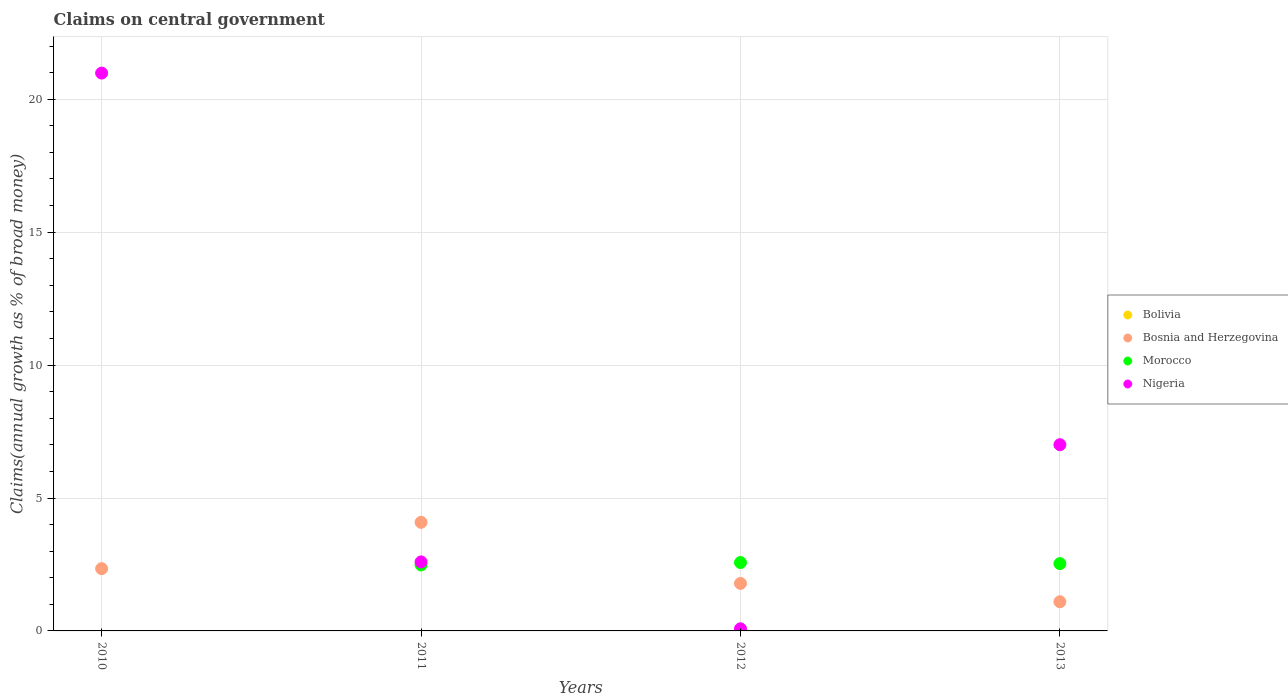How many different coloured dotlines are there?
Your answer should be very brief. 3. What is the percentage of broad money claimed on centeral government in Bosnia and Herzegovina in 2013?
Your answer should be compact. 1.1. Across all years, what is the maximum percentage of broad money claimed on centeral government in Morocco?
Ensure brevity in your answer.  2.57. Across all years, what is the minimum percentage of broad money claimed on centeral government in Nigeria?
Offer a terse response. 0.08. In which year was the percentage of broad money claimed on centeral government in Nigeria maximum?
Your answer should be compact. 2010. What is the total percentage of broad money claimed on centeral government in Nigeria in the graph?
Make the answer very short. 30.66. What is the difference between the percentage of broad money claimed on centeral government in Morocco in 2012 and that in 2013?
Make the answer very short. 0.04. What is the difference between the percentage of broad money claimed on centeral government in Bosnia and Herzegovina in 2011 and the percentage of broad money claimed on centeral government in Morocco in 2013?
Your answer should be compact. 1.55. What is the average percentage of broad money claimed on centeral government in Bosnia and Herzegovina per year?
Your answer should be very brief. 2.33. In the year 2010, what is the difference between the percentage of broad money claimed on centeral government in Bosnia and Herzegovina and percentage of broad money claimed on centeral government in Nigeria?
Provide a succinct answer. -18.64. In how many years, is the percentage of broad money claimed on centeral government in Morocco greater than 16 %?
Offer a very short reply. 0. What is the ratio of the percentage of broad money claimed on centeral government in Morocco in 2012 to that in 2013?
Your answer should be very brief. 1.02. Is the difference between the percentage of broad money claimed on centeral government in Bosnia and Herzegovina in 2011 and 2012 greater than the difference between the percentage of broad money claimed on centeral government in Nigeria in 2011 and 2012?
Keep it short and to the point. No. What is the difference between the highest and the second highest percentage of broad money claimed on centeral government in Nigeria?
Give a very brief answer. 13.98. What is the difference between the highest and the lowest percentage of broad money claimed on centeral government in Nigeria?
Make the answer very short. 20.9. Is the sum of the percentage of broad money claimed on centeral government in Morocco in 2012 and 2013 greater than the maximum percentage of broad money claimed on centeral government in Bosnia and Herzegovina across all years?
Your response must be concise. Yes. Is it the case that in every year, the sum of the percentage of broad money claimed on centeral government in Bosnia and Herzegovina and percentage of broad money claimed on centeral government in Bolivia  is greater than the sum of percentage of broad money claimed on centeral government in Morocco and percentage of broad money claimed on centeral government in Nigeria?
Ensure brevity in your answer.  No. Does the percentage of broad money claimed on centeral government in Nigeria monotonically increase over the years?
Provide a succinct answer. No. Is the percentage of broad money claimed on centeral government in Bolivia strictly greater than the percentage of broad money claimed on centeral government in Morocco over the years?
Keep it short and to the point. No. Is the percentage of broad money claimed on centeral government in Bolivia strictly less than the percentage of broad money claimed on centeral government in Nigeria over the years?
Ensure brevity in your answer.  Yes. How many dotlines are there?
Provide a short and direct response. 3. How many years are there in the graph?
Your answer should be compact. 4. Are the values on the major ticks of Y-axis written in scientific E-notation?
Keep it short and to the point. No. Does the graph contain any zero values?
Ensure brevity in your answer.  Yes. Does the graph contain grids?
Your response must be concise. Yes. What is the title of the graph?
Your answer should be very brief. Claims on central government. Does "Tanzania" appear as one of the legend labels in the graph?
Make the answer very short. No. What is the label or title of the X-axis?
Your answer should be very brief. Years. What is the label or title of the Y-axis?
Provide a succinct answer. Claims(annual growth as % of broad money). What is the Claims(annual growth as % of broad money) of Bolivia in 2010?
Keep it short and to the point. 0. What is the Claims(annual growth as % of broad money) of Bosnia and Herzegovina in 2010?
Make the answer very short. 2.34. What is the Claims(annual growth as % of broad money) of Morocco in 2010?
Offer a very short reply. 0. What is the Claims(annual growth as % of broad money) of Nigeria in 2010?
Your answer should be very brief. 20.98. What is the Claims(annual growth as % of broad money) in Bolivia in 2011?
Offer a very short reply. 0. What is the Claims(annual growth as % of broad money) in Bosnia and Herzegovina in 2011?
Provide a short and direct response. 4.08. What is the Claims(annual growth as % of broad money) of Morocco in 2011?
Keep it short and to the point. 2.48. What is the Claims(annual growth as % of broad money) in Nigeria in 2011?
Offer a terse response. 2.6. What is the Claims(annual growth as % of broad money) in Bolivia in 2012?
Ensure brevity in your answer.  0. What is the Claims(annual growth as % of broad money) of Bosnia and Herzegovina in 2012?
Give a very brief answer. 1.79. What is the Claims(annual growth as % of broad money) in Morocco in 2012?
Your answer should be very brief. 2.57. What is the Claims(annual growth as % of broad money) in Nigeria in 2012?
Give a very brief answer. 0.08. What is the Claims(annual growth as % of broad money) of Bosnia and Herzegovina in 2013?
Offer a very short reply. 1.1. What is the Claims(annual growth as % of broad money) in Morocco in 2013?
Provide a short and direct response. 2.53. What is the Claims(annual growth as % of broad money) in Nigeria in 2013?
Your answer should be compact. 7.01. Across all years, what is the maximum Claims(annual growth as % of broad money) of Bosnia and Herzegovina?
Ensure brevity in your answer.  4.08. Across all years, what is the maximum Claims(annual growth as % of broad money) in Morocco?
Make the answer very short. 2.57. Across all years, what is the maximum Claims(annual growth as % of broad money) of Nigeria?
Your answer should be very brief. 20.98. Across all years, what is the minimum Claims(annual growth as % of broad money) of Bosnia and Herzegovina?
Your response must be concise. 1.1. Across all years, what is the minimum Claims(annual growth as % of broad money) in Morocco?
Make the answer very short. 0. Across all years, what is the minimum Claims(annual growth as % of broad money) in Nigeria?
Keep it short and to the point. 0.08. What is the total Claims(annual growth as % of broad money) of Bolivia in the graph?
Make the answer very short. 0. What is the total Claims(annual growth as % of broad money) in Bosnia and Herzegovina in the graph?
Your response must be concise. 9.31. What is the total Claims(annual growth as % of broad money) in Morocco in the graph?
Your answer should be compact. 7.59. What is the total Claims(annual growth as % of broad money) in Nigeria in the graph?
Make the answer very short. 30.66. What is the difference between the Claims(annual growth as % of broad money) in Bosnia and Herzegovina in 2010 and that in 2011?
Provide a short and direct response. -1.74. What is the difference between the Claims(annual growth as % of broad money) of Nigeria in 2010 and that in 2011?
Ensure brevity in your answer.  18.39. What is the difference between the Claims(annual growth as % of broad money) in Bosnia and Herzegovina in 2010 and that in 2012?
Keep it short and to the point. 0.56. What is the difference between the Claims(annual growth as % of broad money) of Nigeria in 2010 and that in 2012?
Provide a succinct answer. 20.9. What is the difference between the Claims(annual growth as % of broad money) of Bosnia and Herzegovina in 2010 and that in 2013?
Your answer should be compact. 1.25. What is the difference between the Claims(annual growth as % of broad money) of Nigeria in 2010 and that in 2013?
Your response must be concise. 13.98. What is the difference between the Claims(annual growth as % of broad money) in Bosnia and Herzegovina in 2011 and that in 2012?
Provide a short and direct response. 2.3. What is the difference between the Claims(annual growth as % of broad money) in Morocco in 2011 and that in 2012?
Provide a succinct answer. -0.09. What is the difference between the Claims(annual growth as % of broad money) of Nigeria in 2011 and that in 2012?
Keep it short and to the point. 2.52. What is the difference between the Claims(annual growth as % of broad money) of Bosnia and Herzegovina in 2011 and that in 2013?
Make the answer very short. 2.99. What is the difference between the Claims(annual growth as % of broad money) in Morocco in 2011 and that in 2013?
Your answer should be compact. -0.05. What is the difference between the Claims(annual growth as % of broad money) of Nigeria in 2011 and that in 2013?
Your response must be concise. -4.41. What is the difference between the Claims(annual growth as % of broad money) in Bosnia and Herzegovina in 2012 and that in 2013?
Provide a succinct answer. 0.69. What is the difference between the Claims(annual growth as % of broad money) of Morocco in 2012 and that in 2013?
Offer a terse response. 0.04. What is the difference between the Claims(annual growth as % of broad money) of Nigeria in 2012 and that in 2013?
Make the answer very short. -6.93. What is the difference between the Claims(annual growth as % of broad money) of Bosnia and Herzegovina in 2010 and the Claims(annual growth as % of broad money) of Morocco in 2011?
Your answer should be very brief. -0.14. What is the difference between the Claims(annual growth as % of broad money) of Bosnia and Herzegovina in 2010 and the Claims(annual growth as % of broad money) of Nigeria in 2011?
Keep it short and to the point. -0.25. What is the difference between the Claims(annual growth as % of broad money) in Bosnia and Herzegovina in 2010 and the Claims(annual growth as % of broad money) in Morocco in 2012?
Your answer should be compact. -0.23. What is the difference between the Claims(annual growth as % of broad money) in Bosnia and Herzegovina in 2010 and the Claims(annual growth as % of broad money) in Nigeria in 2012?
Offer a very short reply. 2.26. What is the difference between the Claims(annual growth as % of broad money) of Bosnia and Herzegovina in 2010 and the Claims(annual growth as % of broad money) of Morocco in 2013?
Offer a terse response. -0.19. What is the difference between the Claims(annual growth as % of broad money) of Bosnia and Herzegovina in 2010 and the Claims(annual growth as % of broad money) of Nigeria in 2013?
Your answer should be very brief. -4.66. What is the difference between the Claims(annual growth as % of broad money) in Bosnia and Herzegovina in 2011 and the Claims(annual growth as % of broad money) in Morocco in 2012?
Keep it short and to the point. 1.51. What is the difference between the Claims(annual growth as % of broad money) in Bosnia and Herzegovina in 2011 and the Claims(annual growth as % of broad money) in Nigeria in 2012?
Your response must be concise. 4. What is the difference between the Claims(annual growth as % of broad money) of Morocco in 2011 and the Claims(annual growth as % of broad money) of Nigeria in 2012?
Ensure brevity in your answer.  2.4. What is the difference between the Claims(annual growth as % of broad money) in Bosnia and Herzegovina in 2011 and the Claims(annual growth as % of broad money) in Morocco in 2013?
Provide a succinct answer. 1.55. What is the difference between the Claims(annual growth as % of broad money) of Bosnia and Herzegovina in 2011 and the Claims(annual growth as % of broad money) of Nigeria in 2013?
Your answer should be compact. -2.92. What is the difference between the Claims(annual growth as % of broad money) of Morocco in 2011 and the Claims(annual growth as % of broad money) of Nigeria in 2013?
Give a very brief answer. -4.52. What is the difference between the Claims(annual growth as % of broad money) in Bosnia and Herzegovina in 2012 and the Claims(annual growth as % of broad money) in Morocco in 2013?
Ensure brevity in your answer.  -0.74. What is the difference between the Claims(annual growth as % of broad money) of Bosnia and Herzegovina in 2012 and the Claims(annual growth as % of broad money) of Nigeria in 2013?
Give a very brief answer. -5.22. What is the difference between the Claims(annual growth as % of broad money) of Morocco in 2012 and the Claims(annual growth as % of broad money) of Nigeria in 2013?
Provide a short and direct response. -4.43. What is the average Claims(annual growth as % of broad money) of Bolivia per year?
Give a very brief answer. 0. What is the average Claims(annual growth as % of broad money) in Bosnia and Herzegovina per year?
Ensure brevity in your answer.  2.33. What is the average Claims(annual growth as % of broad money) in Morocco per year?
Keep it short and to the point. 1.9. What is the average Claims(annual growth as % of broad money) of Nigeria per year?
Give a very brief answer. 7.67. In the year 2010, what is the difference between the Claims(annual growth as % of broad money) of Bosnia and Herzegovina and Claims(annual growth as % of broad money) of Nigeria?
Your answer should be compact. -18.64. In the year 2011, what is the difference between the Claims(annual growth as % of broad money) in Bosnia and Herzegovina and Claims(annual growth as % of broad money) in Morocco?
Offer a terse response. 1.6. In the year 2011, what is the difference between the Claims(annual growth as % of broad money) in Bosnia and Herzegovina and Claims(annual growth as % of broad money) in Nigeria?
Provide a short and direct response. 1.49. In the year 2011, what is the difference between the Claims(annual growth as % of broad money) in Morocco and Claims(annual growth as % of broad money) in Nigeria?
Give a very brief answer. -0.11. In the year 2012, what is the difference between the Claims(annual growth as % of broad money) of Bosnia and Herzegovina and Claims(annual growth as % of broad money) of Morocco?
Keep it short and to the point. -0.79. In the year 2012, what is the difference between the Claims(annual growth as % of broad money) in Bosnia and Herzegovina and Claims(annual growth as % of broad money) in Nigeria?
Make the answer very short. 1.71. In the year 2012, what is the difference between the Claims(annual growth as % of broad money) of Morocco and Claims(annual growth as % of broad money) of Nigeria?
Your answer should be very brief. 2.49. In the year 2013, what is the difference between the Claims(annual growth as % of broad money) of Bosnia and Herzegovina and Claims(annual growth as % of broad money) of Morocco?
Give a very brief answer. -1.43. In the year 2013, what is the difference between the Claims(annual growth as % of broad money) of Bosnia and Herzegovina and Claims(annual growth as % of broad money) of Nigeria?
Ensure brevity in your answer.  -5.91. In the year 2013, what is the difference between the Claims(annual growth as % of broad money) of Morocco and Claims(annual growth as % of broad money) of Nigeria?
Keep it short and to the point. -4.47. What is the ratio of the Claims(annual growth as % of broad money) of Bosnia and Herzegovina in 2010 to that in 2011?
Provide a short and direct response. 0.57. What is the ratio of the Claims(annual growth as % of broad money) of Nigeria in 2010 to that in 2011?
Provide a short and direct response. 8.08. What is the ratio of the Claims(annual growth as % of broad money) of Bosnia and Herzegovina in 2010 to that in 2012?
Give a very brief answer. 1.31. What is the ratio of the Claims(annual growth as % of broad money) in Nigeria in 2010 to that in 2012?
Offer a terse response. 263.48. What is the ratio of the Claims(annual growth as % of broad money) of Bosnia and Herzegovina in 2010 to that in 2013?
Provide a short and direct response. 2.14. What is the ratio of the Claims(annual growth as % of broad money) of Nigeria in 2010 to that in 2013?
Give a very brief answer. 3. What is the ratio of the Claims(annual growth as % of broad money) in Bosnia and Herzegovina in 2011 to that in 2012?
Offer a very short reply. 2.29. What is the ratio of the Claims(annual growth as % of broad money) in Morocco in 2011 to that in 2012?
Offer a terse response. 0.97. What is the ratio of the Claims(annual growth as % of broad money) of Nigeria in 2011 to that in 2012?
Provide a short and direct response. 32.59. What is the ratio of the Claims(annual growth as % of broad money) of Bosnia and Herzegovina in 2011 to that in 2013?
Give a very brief answer. 3.72. What is the ratio of the Claims(annual growth as % of broad money) in Morocco in 2011 to that in 2013?
Make the answer very short. 0.98. What is the ratio of the Claims(annual growth as % of broad money) in Nigeria in 2011 to that in 2013?
Your answer should be very brief. 0.37. What is the ratio of the Claims(annual growth as % of broad money) of Bosnia and Herzegovina in 2012 to that in 2013?
Ensure brevity in your answer.  1.63. What is the ratio of the Claims(annual growth as % of broad money) of Morocco in 2012 to that in 2013?
Keep it short and to the point. 1.02. What is the ratio of the Claims(annual growth as % of broad money) in Nigeria in 2012 to that in 2013?
Give a very brief answer. 0.01. What is the difference between the highest and the second highest Claims(annual growth as % of broad money) in Bosnia and Herzegovina?
Your answer should be very brief. 1.74. What is the difference between the highest and the second highest Claims(annual growth as % of broad money) in Morocco?
Keep it short and to the point. 0.04. What is the difference between the highest and the second highest Claims(annual growth as % of broad money) of Nigeria?
Your answer should be very brief. 13.98. What is the difference between the highest and the lowest Claims(annual growth as % of broad money) of Bosnia and Herzegovina?
Keep it short and to the point. 2.99. What is the difference between the highest and the lowest Claims(annual growth as % of broad money) of Morocco?
Ensure brevity in your answer.  2.57. What is the difference between the highest and the lowest Claims(annual growth as % of broad money) in Nigeria?
Ensure brevity in your answer.  20.9. 